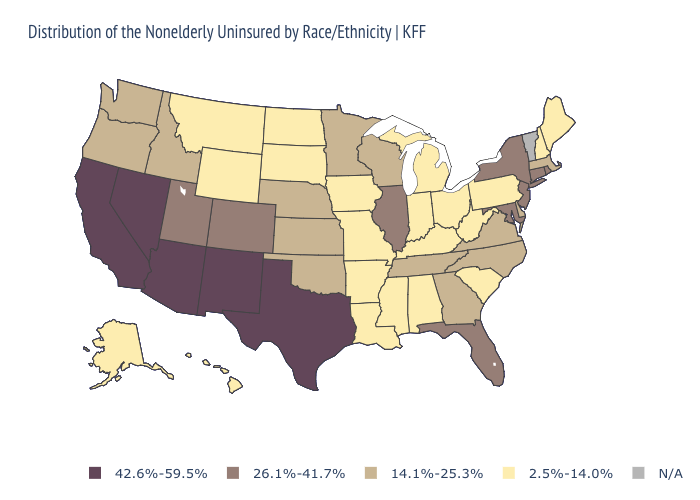What is the highest value in states that border South Dakota?
Short answer required. 14.1%-25.3%. Does the first symbol in the legend represent the smallest category?
Concise answer only. No. What is the value of Massachusetts?
Keep it brief. 14.1%-25.3%. Among the states that border Missouri , which have the highest value?
Write a very short answer. Illinois. What is the value of Nebraska?
Give a very brief answer. 14.1%-25.3%. Name the states that have a value in the range 14.1%-25.3%?
Write a very short answer. Delaware, Georgia, Idaho, Kansas, Massachusetts, Minnesota, Nebraska, North Carolina, Oklahoma, Oregon, Tennessee, Virginia, Washington, Wisconsin. What is the value of Minnesota?
Keep it brief. 14.1%-25.3%. Does Arkansas have the highest value in the South?
Answer briefly. No. Name the states that have a value in the range N/A?
Be succinct. Vermont. Name the states that have a value in the range 2.5%-14.0%?
Give a very brief answer. Alabama, Alaska, Arkansas, Hawaii, Indiana, Iowa, Kentucky, Louisiana, Maine, Michigan, Mississippi, Missouri, Montana, New Hampshire, North Dakota, Ohio, Pennsylvania, South Carolina, South Dakota, West Virginia, Wyoming. Among the states that border Vermont , which have the highest value?
Concise answer only. New York. Name the states that have a value in the range 2.5%-14.0%?
Quick response, please. Alabama, Alaska, Arkansas, Hawaii, Indiana, Iowa, Kentucky, Louisiana, Maine, Michigan, Mississippi, Missouri, Montana, New Hampshire, North Dakota, Ohio, Pennsylvania, South Carolina, South Dakota, West Virginia, Wyoming. Which states hav the highest value in the South?
Concise answer only. Texas. Name the states that have a value in the range N/A?
Be succinct. Vermont. Which states have the lowest value in the USA?
Write a very short answer. Alabama, Alaska, Arkansas, Hawaii, Indiana, Iowa, Kentucky, Louisiana, Maine, Michigan, Mississippi, Missouri, Montana, New Hampshire, North Dakota, Ohio, Pennsylvania, South Carolina, South Dakota, West Virginia, Wyoming. 